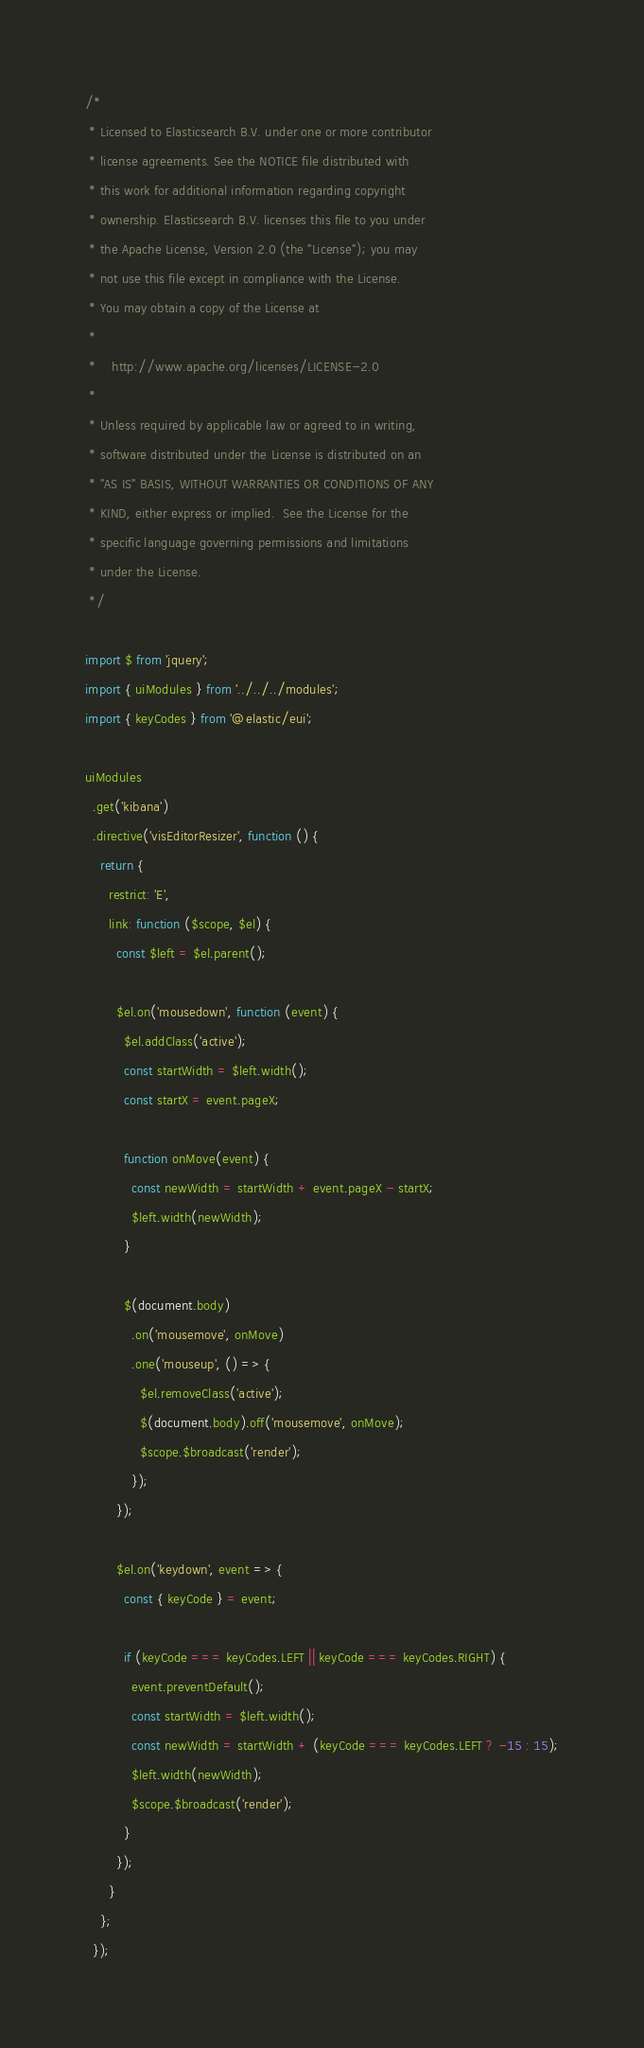Convert code to text. <code><loc_0><loc_0><loc_500><loc_500><_JavaScript_>/*
 * Licensed to Elasticsearch B.V. under one or more contributor
 * license agreements. See the NOTICE file distributed with
 * this work for additional information regarding copyright
 * ownership. Elasticsearch B.V. licenses this file to you under
 * the Apache License, Version 2.0 (the "License"); you may
 * not use this file except in compliance with the License.
 * You may obtain a copy of the License at
 *
 *    http://www.apache.org/licenses/LICENSE-2.0
 *
 * Unless required by applicable law or agreed to in writing,
 * software distributed under the License is distributed on an
 * "AS IS" BASIS, WITHOUT WARRANTIES OR CONDITIONS OF ANY
 * KIND, either express or implied.  See the License for the
 * specific language governing permissions and limitations
 * under the License.
 */

import $ from 'jquery';
import { uiModules } from '../../../modules';
import { keyCodes } from '@elastic/eui';

uiModules
  .get('kibana')
  .directive('visEditorResizer', function () {
    return {
      restrict: 'E',
      link: function ($scope, $el) {
        const $left = $el.parent();

        $el.on('mousedown', function (event) {
          $el.addClass('active');
          const startWidth = $left.width();
          const startX = event.pageX;

          function onMove(event) {
            const newWidth = startWidth + event.pageX - startX;
            $left.width(newWidth);
          }

          $(document.body)
            .on('mousemove', onMove)
            .one('mouseup', () => {
              $el.removeClass('active');
              $(document.body).off('mousemove', onMove);
              $scope.$broadcast('render');
            });
        });

        $el.on('keydown', event => {
          const { keyCode } = event;

          if (keyCode === keyCodes.LEFT || keyCode === keyCodes.RIGHT) {
            event.preventDefault();
            const startWidth = $left.width();
            const newWidth = startWidth + (keyCode === keyCodes.LEFT ? -15 : 15);
            $left.width(newWidth);
            $scope.$broadcast('render');
          }
        });
      }
    };
  });
</code> 